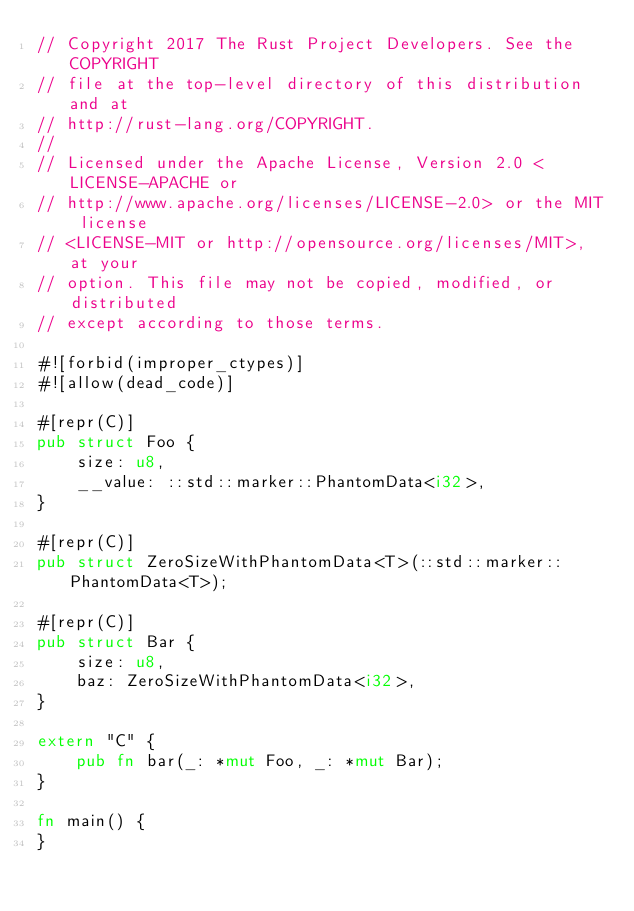<code> <loc_0><loc_0><loc_500><loc_500><_Rust_>// Copyright 2017 The Rust Project Developers. See the COPYRIGHT
// file at the top-level directory of this distribution and at
// http://rust-lang.org/COPYRIGHT.
//
// Licensed under the Apache License, Version 2.0 <LICENSE-APACHE or
// http://www.apache.org/licenses/LICENSE-2.0> or the MIT license
// <LICENSE-MIT or http://opensource.org/licenses/MIT>, at your
// option. This file may not be copied, modified, or distributed
// except according to those terms.

#![forbid(improper_ctypes)]
#![allow(dead_code)]

#[repr(C)]
pub struct Foo {
    size: u8,
    __value: ::std::marker::PhantomData<i32>,
}

#[repr(C)]
pub struct ZeroSizeWithPhantomData<T>(::std::marker::PhantomData<T>);

#[repr(C)]
pub struct Bar {
    size: u8,
    baz: ZeroSizeWithPhantomData<i32>,
}

extern "C" {
    pub fn bar(_: *mut Foo, _: *mut Bar);
}

fn main() {
}
</code> 